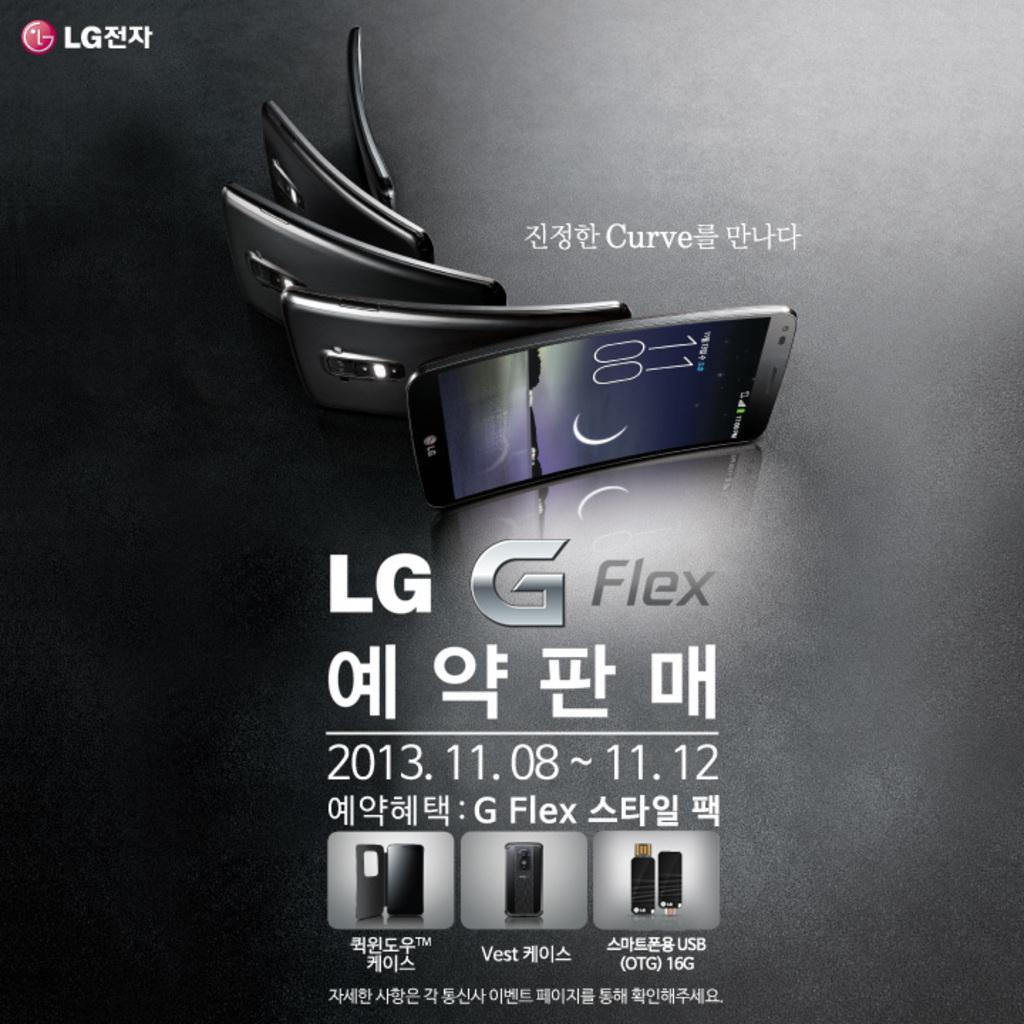<image>
Render a clear and concise summary of the photo. An add for the LG G Flex with the product shown.. 